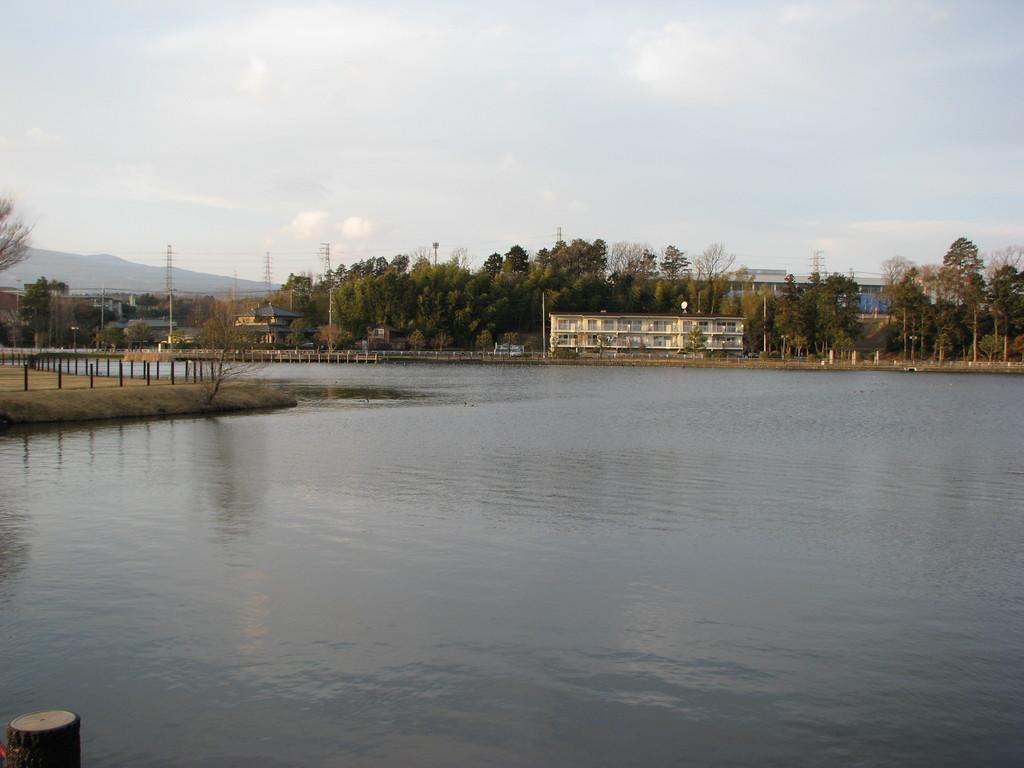How would you summarize this image in a sentence or two? In this picture we can see a lake and behind the lake there are buildings, electric poles with cables, trees, hill and the sky. 